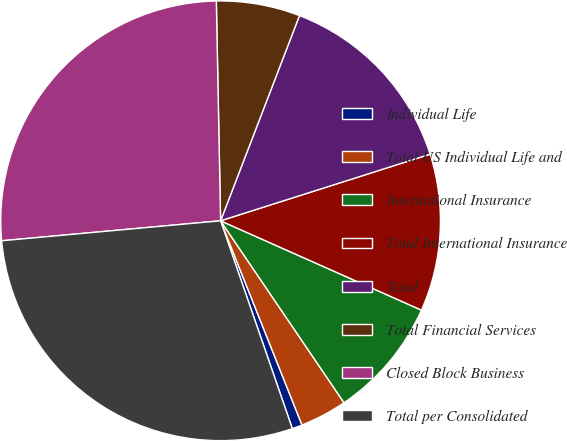<chart> <loc_0><loc_0><loc_500><loc_500><pie_chart><fcel>Individual Life<fcel>Total US Individual Life and<fcel>International Insurance<fcel>Total International Insurance<fcel>Total<fcel>Total Financial Services<fcel>Closed Block Business<fcel>Total per Consolidated<nl><fcel>0.75%<fcel>3.45%<fcel>8.85%<fcel>11.56%<fcel>14.26%<fcel>6.15%<fcel>26.14%<fcel>28.84%<nl></chart> 